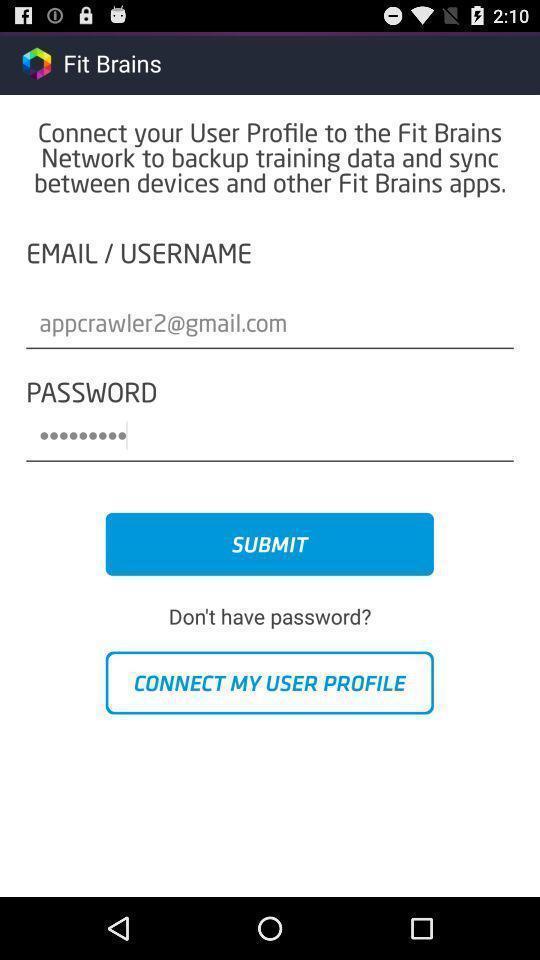Provide a detailed account of this screenshot. Submit page for connecting to an app. 